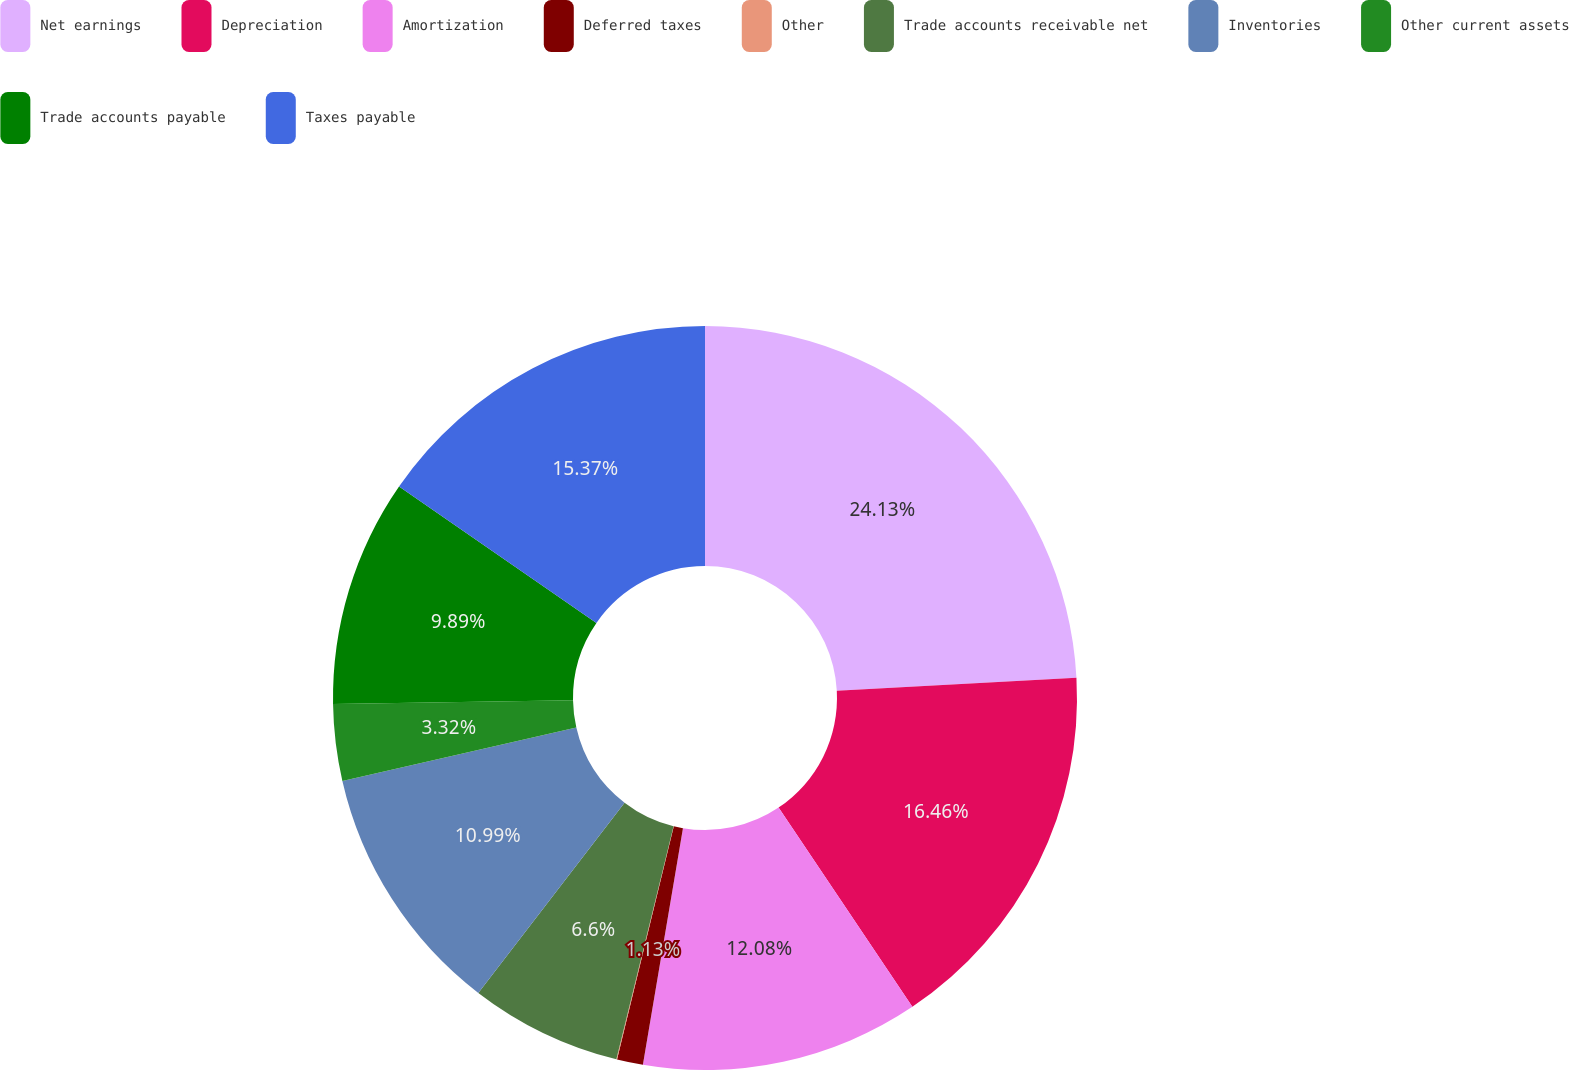<chart> <loc_0><loc_0><loc_500><loc_500><pie_chart><fcel>Net earnings<fcel>Depreciation<fcel>Amortization<fcel>Deferred taxes<fcel>Other<fcel>Trade accounts receivable net<fcel>Inventories<fcel>Other current assets<fcel>Trade accounts payable<fcel>Taxes payable<nl><fcel>24.13%<fcel>16.46%<fcel>12.08%<fcel>1.13%<fcel>0.03%<fcel>6.6%<fcel>10.99%<fcel>3.32%<fcel>9.89%<fcel>15.37%<nl></chart> 